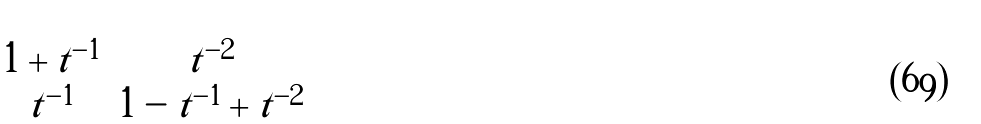Convert formula to latex. <formula><loc_0><loc_0><loc_500><loc_500>\begin{bmatrix} 1 + t ^ { - 1 } & t ^ { - 2 } \\ t ^ { - 1 } & 1 - t ^ { - 1 } + t ^ { - 2 } \end{bmatrix}</formula> 